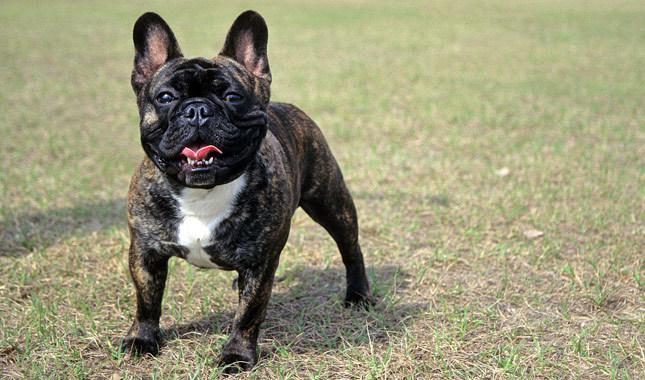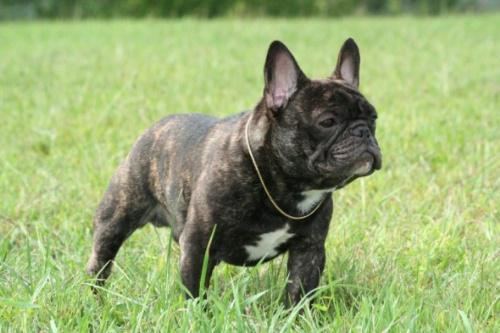The first image is the image on the left, the second image is the image on the right. Considering the images on both sides, is "There are three dogs" valid? Answer yes or no. No. 